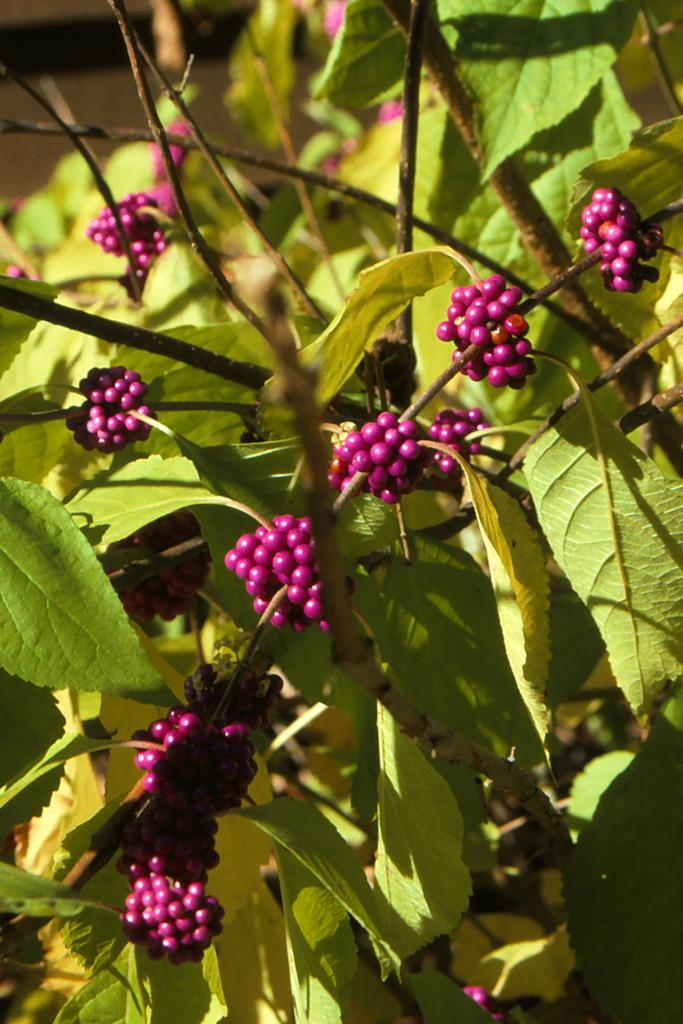What type of plant is visible in the image? There is a plant in the image. What can be found on the plant? The plant has berries. What color are the leaves of the plant? The plant has green leaves. What type of meal is being prepared with the plant in the image? There is no indication in the image that the plant is being used for a meal, as it is simply a plant with berries and green leaves. 